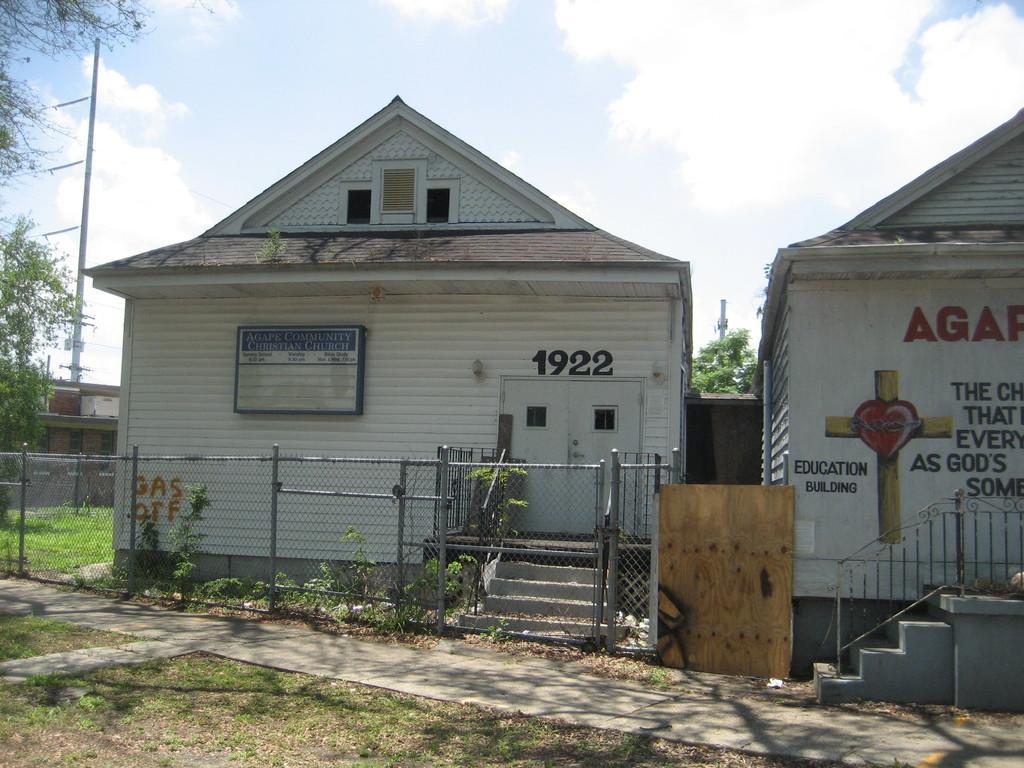How would you summarize this image in a sentence or two? In this image I can see two buildings in white color, in front I can see railing, trees in green color, an electric pole and sky is in white color. 